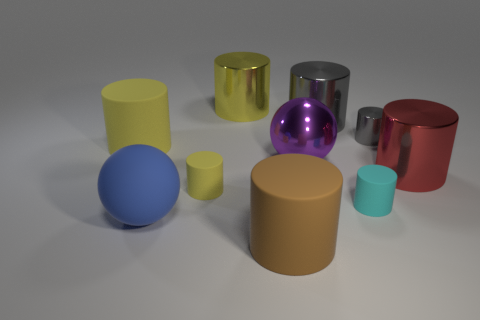Subtract all big cylinders. How many cylinders are left? 3 Add 5 large rubber cylinders. How many large rubber cylinders are left? 7 Add 4 small yellow matte cylinders. How many small yellow matte cylinders exist? 5 Subtract all yellow cylinders. How many cylinders are left? 5 Subtract 0 blue cylinders. How many objects are left? 10 Subtract all cylinders. How many objects are left? 2 Subtract 1 spheres. How many spheres are left? 1 Subtract all cyan spheres. Subtract all gray cylinders. How many spheres are left? 2 Subtract all cyan cylinders. How many green spheres are left? 0 Subtract all large purple cylinders. Subtract all big yellow things. How many objects are left? 8 